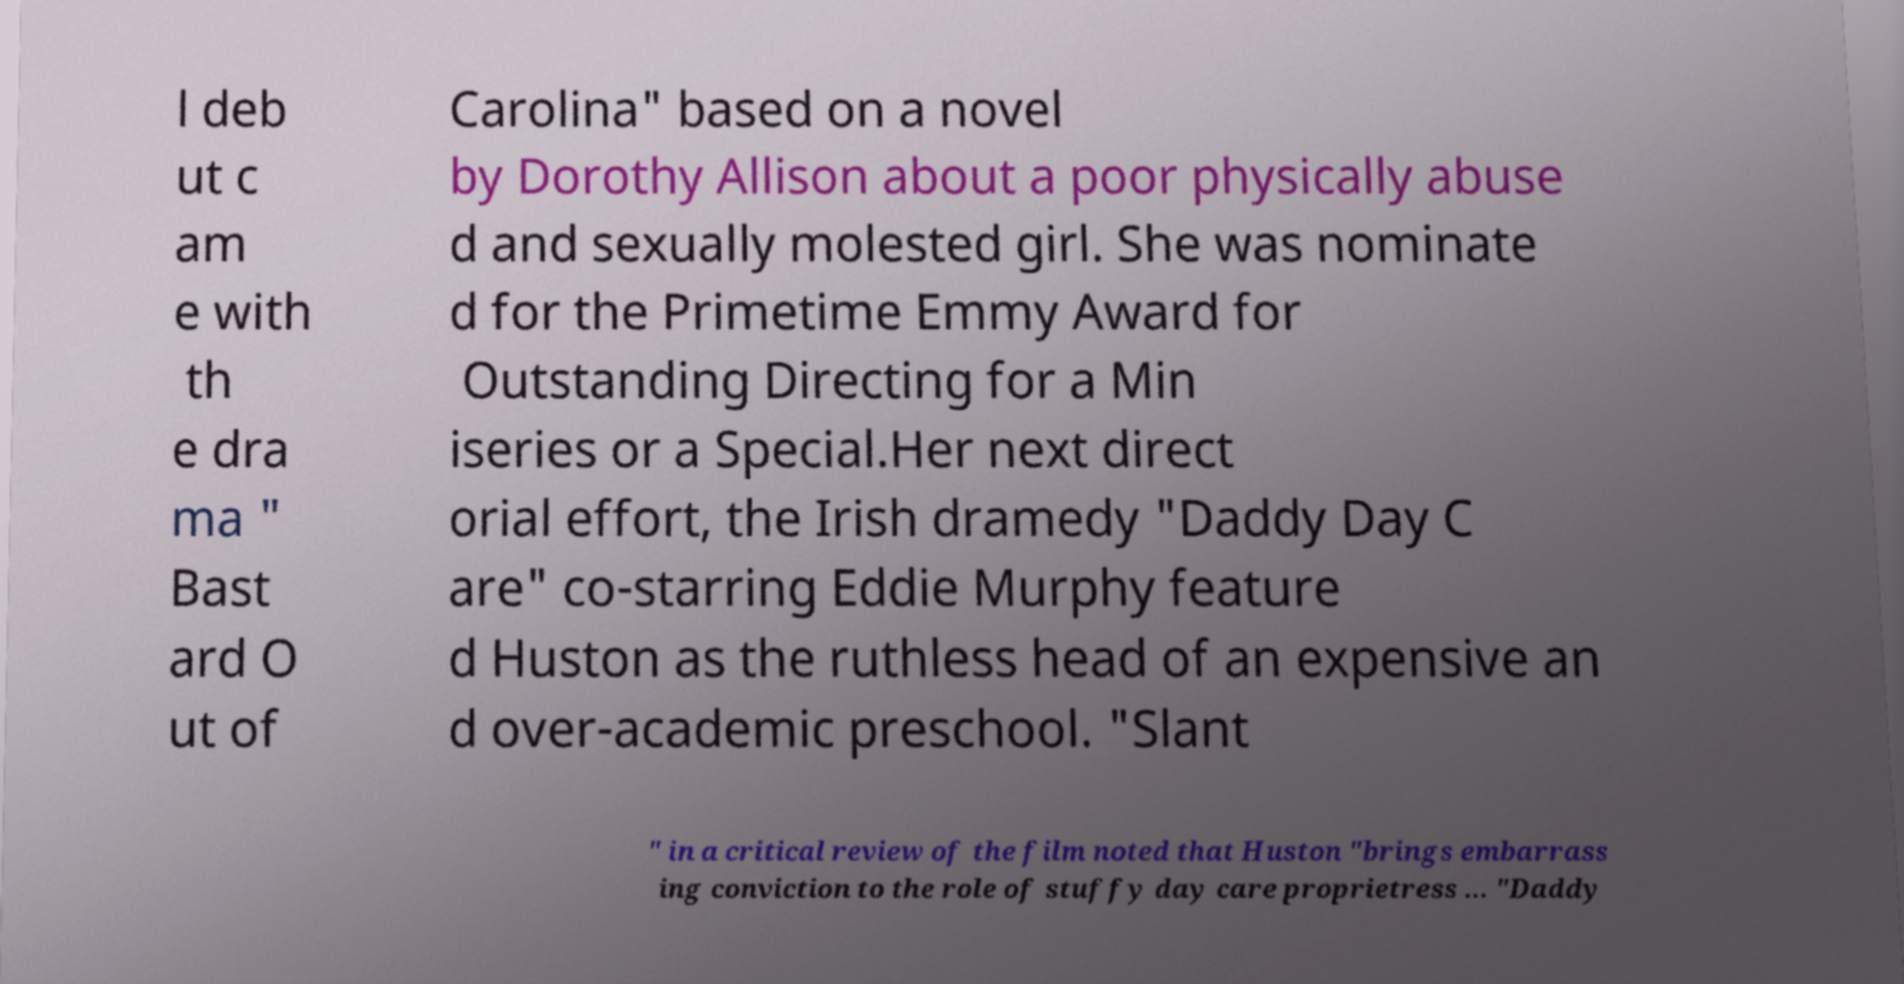I need the written content from this picture converted into text. Can you do that? l deb ut c am e with th e dra ma " Bast ard O ut of Carolina" based on a novel by Dorothy Allison about a poor physically abuse d and sexually molested girl. She was nominate d for the Primetime Emmy Award for Outstanding Directing for a Min iseries or a Special.Her next direct orial effort, the Irish dramedy "Daddy Day C are" co-starring Eddie Murphy feature d Huston as the ruthless head of an expensive an d over-academic preschool. "Slant " in a critical review of the film noted that Huston "brings embarrass ing conviction to the role of stuffy day care proprietress ... "Daddy 